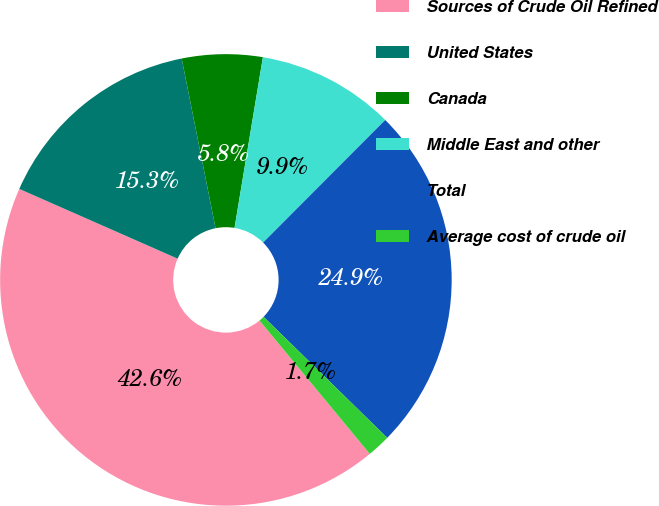Convert chart. <chart><loc_0><loc_0><loc_500><loc_500><pie_chart><fcel>Sources of Crude Oil Refined<fcel>United States<fcel>Canada<fcel>Middle East and other<fcel>Total<fcel>Average cost of crude oil<nl><fcel>42.6%<fcel>15.26%<fcel>5.76%<fcel>9.85%<fcel>24.86%<fcel>1.67%<nl></chart> 